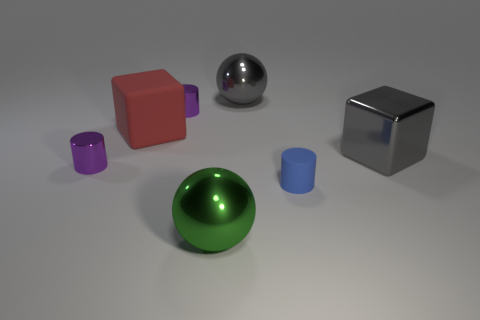Add 3 yellow shiny cubes. How many objects exist? 10 Subtract all blocks. How many objects are left? 5 Subtract 1 gray balls. How many objects are left? 6 Subtract all big matte blocks. Subtract all blue rubber cylinders. How many objects are left? 5 Add 2 tiny blue cylinders. How many tiny blue cylinders are left? 3 Add 7 tiny yellow matte blocks. How many tiny yellow matte blocks exist? 7 